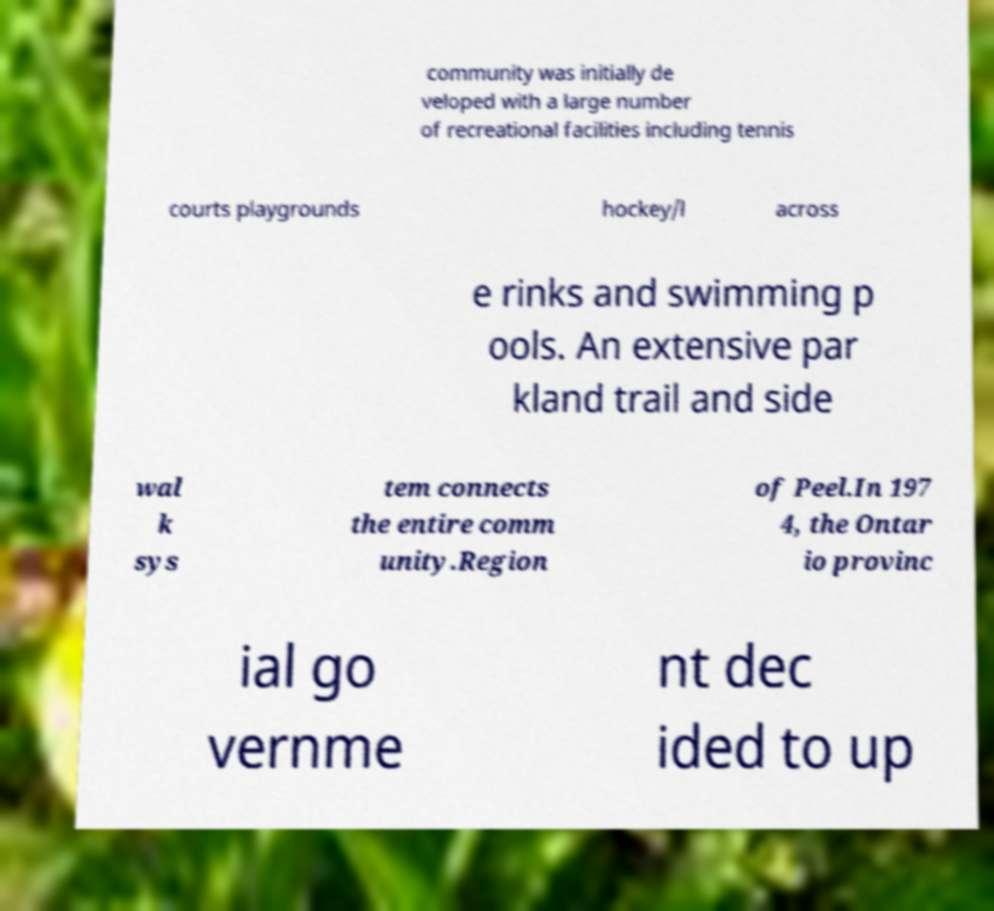Can you read and provide the text displayed in the image?This photo seems to have some interesting text. Can you extract and type it out for me? community was initially de veloped with a large number of recreational facilities including tennis courts playgrounds hockey/l across e rinks and swimming p ools. An extensive par kland trail and side wal k sys tem connects the entire comm unity.Region of Peel.In 197 4, the Ontar io provinc ial go vernme nt dec ided to up 